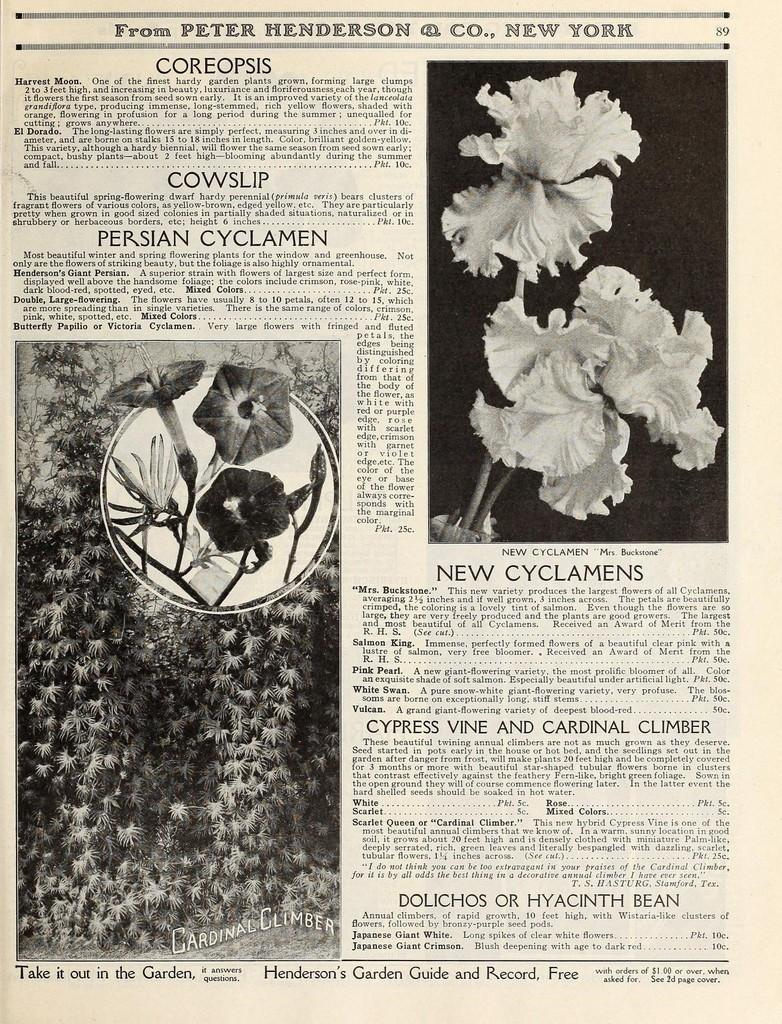What is the main subject of the poster in the image? The poster contains pictures of flowers. Are there any words or phrases on the poster? Yes, there is text written on the poster. What type of rifle is depicted in the poster? There is no rifle present in the poster; it features pictures of flowers and text. What arithmetic problem is solved on the poster? There is no arithmetic problem present on the poster; it contains pictures of flowers and text. 